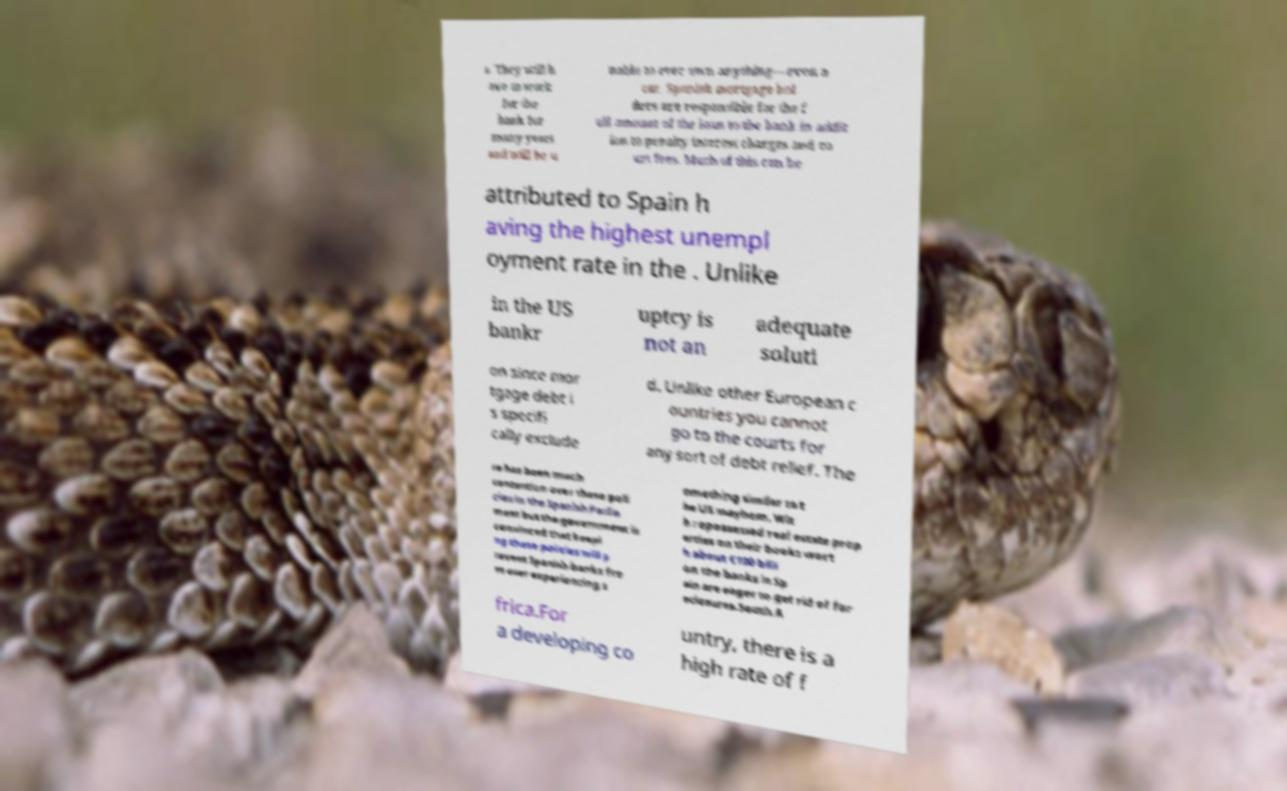Could you assist in decoding the text presented in this image and type it out clearly? s. They will h ave to work for the bank for many years and will be u nable to ever own anything—even a car. Spanish mortgage hol ders are responsible for the f ull amount of the loan to the bank in addit ion to penalty interest charges and co urt fees. Much of this can be attributed to Spain h aving the highest unempl oyment rate in the . Unlike in the US bankr uptcy is not an adequate soluti on since mor tgage debt i s specifi cally exclude d. Unlike other European c ountries you cannot go to the courts for any sort of debt relief. The re has been much contention over these poli cies in the Spanish Parlia ment but the government is convinced that keepi ng these policies will p revent Spanish banks fro m ever experiencing s omething similar to t he US mayhem. Wit h repossessed real estate prop erties on their books wort h about €100 billi on the banks in Sp ain are eager to get rid of for eclosures.South A frica.For a developing co untry, there is a high rate of f 